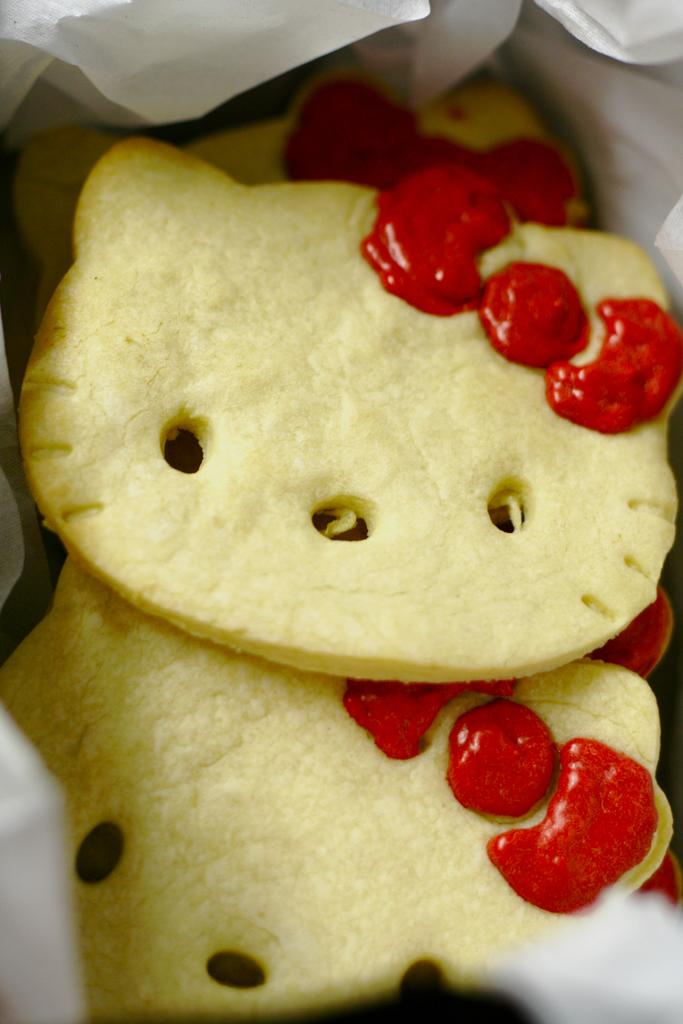What can be seen in the image? There is food visible in the image. What type of fruit can be seen growing in the cemetery in the image? There is no cemetery or fruit present in the image; it only features food. 